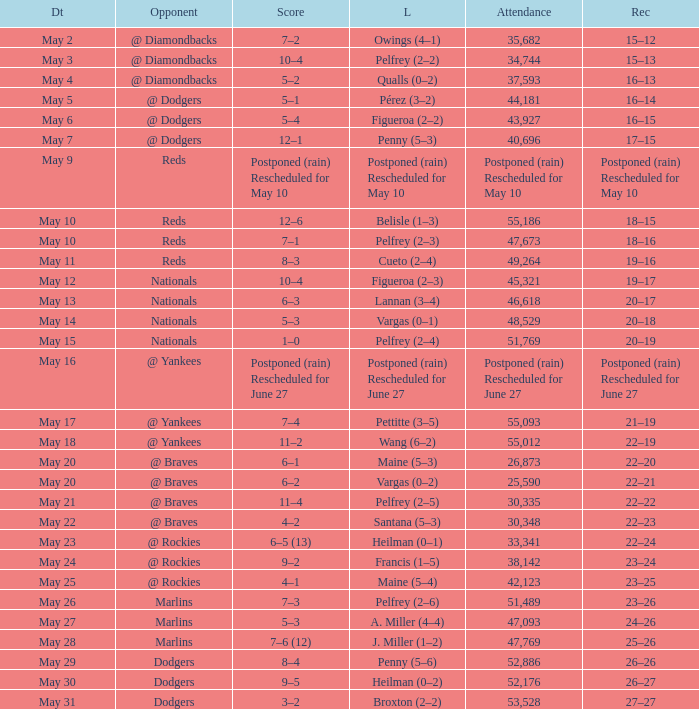Record of 19–16 occurred on what date? May 11. 